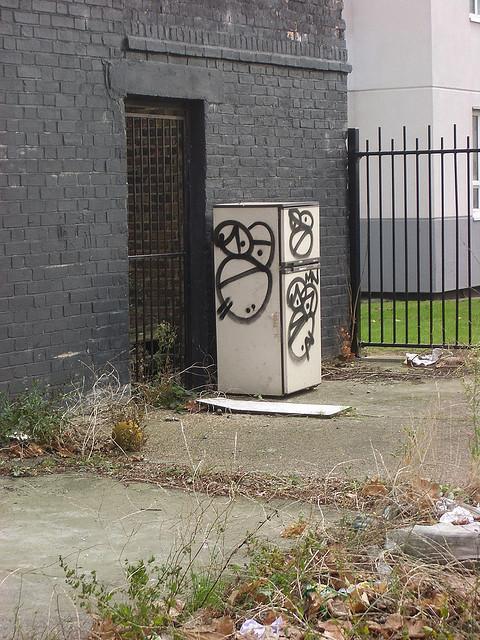How many cars contain coal?
Give a very brief answer. 0. 